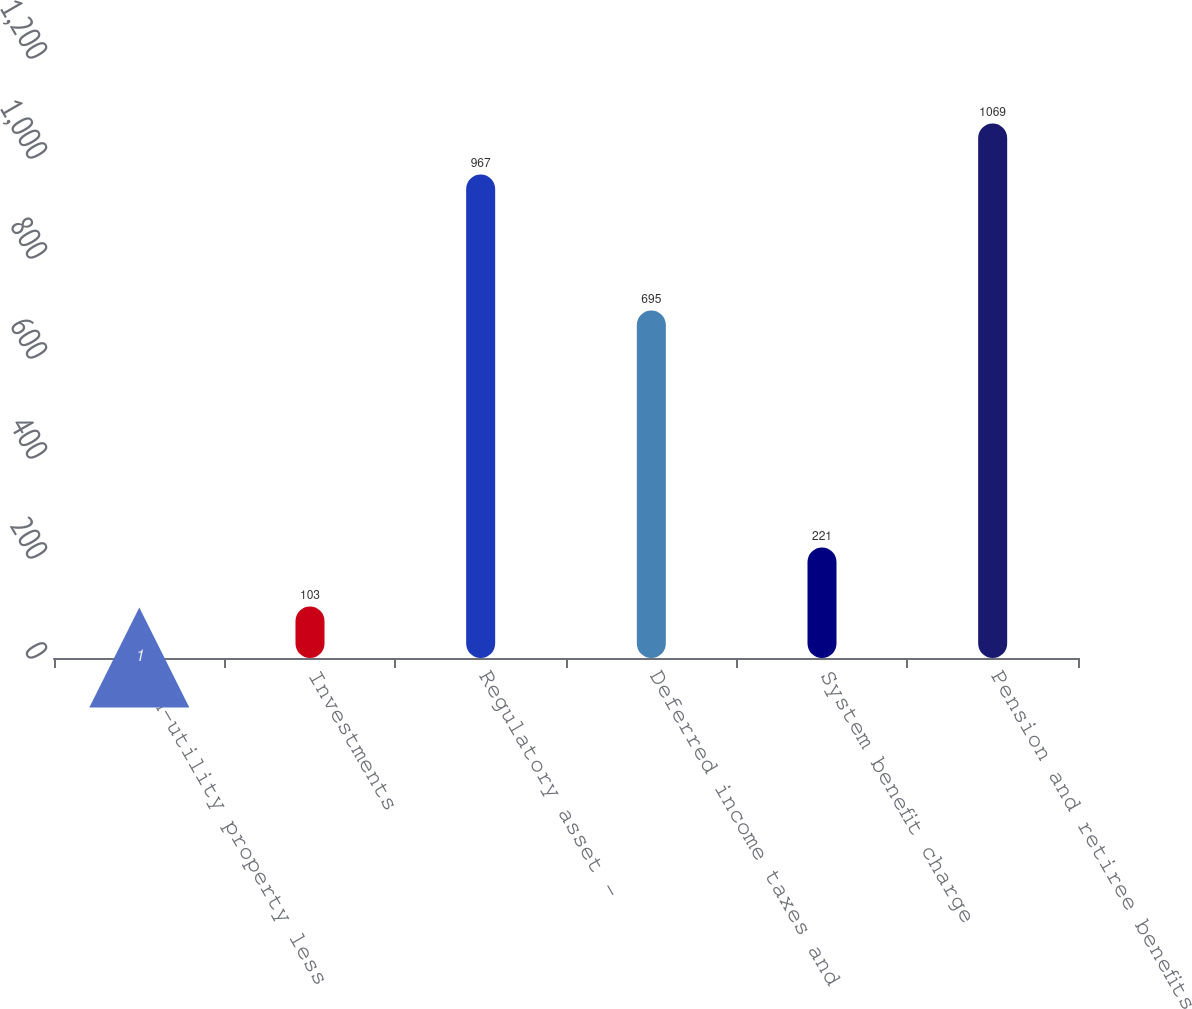Convert chart to OTSL. <chart><loc_0><loc_0><loc_500><loc_500><bar_chart><fcel>Non-utility property less<fcel>Investments<fcel>Regulatory asset -<fcel>Deferred income taxes and<fcel>System benefit charge<fcel>Pension and retiree benefits<nl><fcel>1<fcel>103<fcel>967<fcel>695<fcel>221<fcel>1069<nl></chart> 